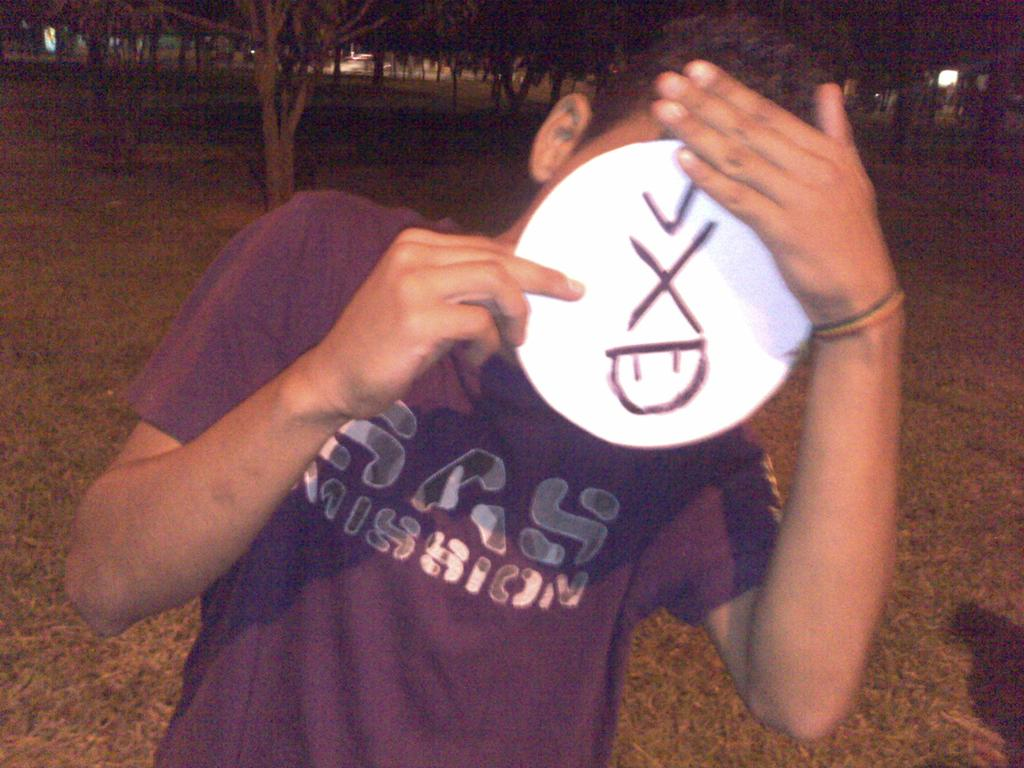<image>
Offer a succinct explanation of the picture presented. the word X is on an item in front of a man 